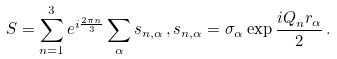<formula> <loc_0><loc_0><loc_500><loc_500>S = \sum _ { n = 1 } ^ { 3 } e ^ { i \frac { 2 \pi n } { 3 } } \sum _ { \alpha } s _ { n , \alpha } \, , s _ { n , \alpha } = \sigma _ { \alpha } \exp \frac { { i Q } _ { n } { r } _ { \alpha } } { 2 } \, .</formula> 